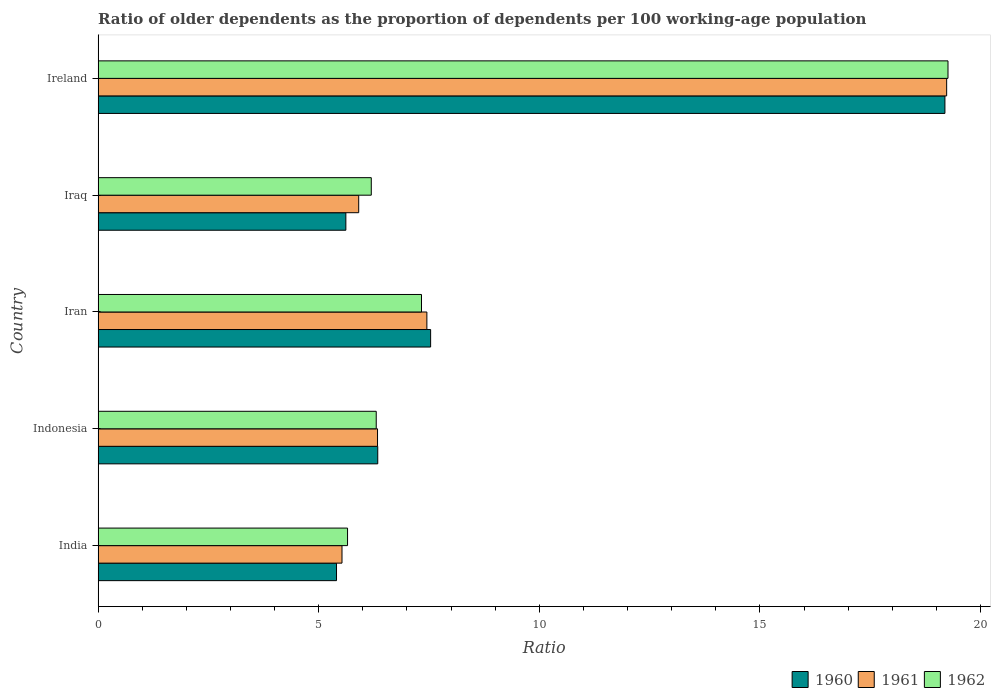How many different coloured bars are there?
Provide a short and direct response. 3. Are the number of bars per tick equal to the number of legend labels?
Your answer should be very brief. Yes. What is the label of the 2nd group of bars from the top?
Provide a short and direct response. Iraq. In how many cases, is the number of bars for a given country not equal to the number of legend labels?
Give a very brief answer. 0. What is the age dependency ratio(old) in 1961 in Iraq?
Make the answer very short. 5.91. Across all countries, what is the maximum age dependency ratio(old) in 1962?
Provide a succinct answer. 19.26. Across all countries, what is the minimum age dependency ratio(old) in 1961?
Your answer should be very brief. 5.53. In which country was the age dependency ratio(old) in 1961 maximum?
Keep it short and to the point. Ireland. What is the total age dependency ratio(old) in 1961 in the graph?
Ensure brevity in your answer.  44.45. What is the difference between the age dependency ratio(old) in 1962 in Iran and that in Ireland?
Ensure brevity in your answer.  -11.93. What is the difference between the age dependency ratio(old) in 1962 in India and the age dependency ratio(old) in 1960 in Iraq?
Provide a succinct answer. 0.04. What is the average age dependency ratio(old) in 1960 per country?
Provide a succinct answer. 8.82. What is the difference between the age dependency ratio(old) in 1962 and age dependency ratio(old) in 1961 in Iraq?
Make the answer very short. 0.28. In how many countries, is the age dependency ratio(old) in 1962 greater than 10 ?
Give a very brief answer. 1. What is the ratio of the age dependency ratio(old) in 1960 in Iran to that in Ireland?
Give a very brief answer. 0.39. Is the age dependency ratio(old) in 1961 in India less than that in Iran?
Provide a succinct answer. Yes. What is the difference between the highest and the second highest age dependency ratio(old) in 1960?
Your answer should be very brief. 11.66. What is the difference between the highest and the lowest age dependency ratio(old) in 1961?
Make the answer very short. 13.71. Is the sum of the age dependency ratio(old) in 1962 in Indonesia and Ireland greater than the maximum age dependency ratio(old) in 1961 across all countries?
Provide a succinct answer. Yes. What does the 3rd bar from the top in Iraq represents?
Your response must be concise. 1960. Is it the case that in every country, the sum of the age dependency ratio(old) in 1962 and age dependency ratio(old) in 1961 is greater than the age dependency ratio(old) in 1960?
Offer a terse response. Yes. How many countries are there in the graph?
Ensure brevity in your answer.  5. What is the difference between two consecutive major ticks on the X-axis?
Make the answer very short. 5. Does the graph contain any zero values?
Make the answer very short. No. Does the graph contain grids?
Keep it short and to the point. No. Where does the legend appear in the graph?
Keep it short and to the point. Bottom right. How many legend labels are there?
Offer a very short reply. 3. How are the legend labels stacked?
Keep it short and to the point. Horizontal. What is the title of the graph?
Your response must be concise. Ratio of older dependents as the proportion of dependents per 100 working-age population. What is the label or title of the X-axis?
Offer a very short reply. Ratio. What is the label or title of the Y-axis?
Keep it short and to the point. Country. What is the Ratio in 1960 in India?
Provide a succinct answer. 5.4. What is the Ratio of 1961 in India?
Make the answer very short. 5.53. What is the Ratio of 1962 in India?
Ensure brevity in your answer.  5.65. What is the Ratio of 1960 in Indonesia?
Keep it short and to the point. 6.34. What is the Ratio in 1961 in Indonesia?
Keep it short and to the point. 6.33. What is the Ratio in 1962 in Indonesia?
Provide a succinct answer. 6.3. What is the Ratio of 1960 in Iran?
Offer a terse response. 7.54. What is the Ratio of 1961 in Iran?
Give a very brief answer. 7.45. What is the Ratio in 1962 in Iran?
Provide a succinct answer. 7.33. What is the Ratio of 1960 in Iraq?
Your answer should be compact. 5.62. What is the Ratio of 1961 in Iraq?
Your answer should be compact. 5.91. What is the Ratio in 1962 in Iraq?
Offer a very short reply. 6.19. What is the Ratio in 1960 in Ireland?
Provide a short and direct response. 19.19. What is the Ratio in 1961 in Ireland?
Your response must be concise. 19.23. What is the Ratio in 1962 in Ireland?
Keep it short and to the point. 19.26. Across all countries, what is the maximum Ratio of 1960?
Offer a terse response. 19.19. Across all countries, what is the maximum Ratio in 1961?
Make the answer very short. 19.23. Across all countries, what is the maximum Ratio in 1962?
Make the answer very short. 19.26. Across all countries, what is the minimum Ratio in 1960?
Offer a very short reply. 5.4. Across all countries, what is the minimum Ratio in 1961?
Your answer should be very brief. 5.53. Across all countries, what is the minimum Ratio in 1962?
Your answer should be compact. 5.65. What is the total Ratio of 1960 in the graph?
Make the answer very short. 44.09. What is the total Ratio of 1961 in the graph?
Your answer should be compact. 44.45. What is the total Ratio of 1962 in the graph?
Keep it short and to the point. 44.74. What is the difference between the Ratio of 1960 in India and that in Indonesia?
Your response must be concise. -0.93. What is the difference between the Ratio in 1961 in India and that in Indonesia?
Give a very brief answer. -0.81. What is the difference between the Ratio of 1962 in India and that in Indonesia?
Provide a succinct answer. -0.65. What is the difference between the Ratio in 1960 in India and that in Iran?
Provide a short and direct response. -2.13. What is the difference between the Ratio of 1961 in India and that in Iran?
Make the answer very short. -1.92. What is the difference between the Ratio of 1962 in India and that in Iran?
Offer a very short reply. -1.68. What is the difference between the Ratio of 1960 in India and that in Iraq?
Give a very brief answer. -0.21. What is the difference between the Ratio of 1961 in India and that in Iraq?
Offer a very short reply. -0.38. What is the difference between the Ratio in 1962 in India and that in Iraq?
Provide a succinct answer. -0.54. What is the difference between the Ratio in 1960 in India and that in Ireland?
Ensure brevity in your answer.  -13.79. What is the difference between the Ratio of 1961 in India and that in Ireland?
Your answer should be very brief. -13.71. What is the difference between the Ratio in 1962 in India and that in Ireland?
Offer a very short reply. -13.61. What is the difference between the Ratio in 1960 in Indonesia and that in Iran?
Provide a succinct answer. -1.2. What is the difference between the Ratio of 1961 in Indonesia and that in Iran?
Give a very brief answer. -1.12. What is the difference between the Ratio of 1962 in Indonesia and that in Iran?
Offer a very short reply. -1.03. What is the difference between the Ratio in 1960 in Indonesia and that in Iraq?
Keep it short and to the point. 0.72. What is the difference between the Ratio of 1961 in Indonesia and that in Iraq?
Your response must be concise. 0.43. What is the difference between the Ratio in 1962 in Indonesia and that in Iraq?
Ensure brevity in your answer.  0.11. What is the difference between the Ratio of 1960 in Indonesia and that in Ireland?
Your answer should be compact. -12.86. What is the difference between the Ratio of 1961 in Indonesia and that in Ireland?
Make the answer very short. -12.9. What is the difference between the Ratio of 1962 in Indonesia and that in Ireland?
Make the answer very short. -12.96. What is the difference between the Ratio of 1960 in Iran and that in Iraq?
Ensure brevity in your answer.  1.92. What is the difference between the Ratio in 1961 in Iran and that in Iraq?
Give a very brief answer. 1.55. What is the difference between the Ratio of 1962 in Iran and that in Iraq?
Offer a terse response. 1.14. What is the difference between the Ratio in 1960 in Iran and that in Ireland?
Your answer should be very brief. -11.66. What is the difference between the Ratio in 1961 in Iran and that in Ireland?
Keep it short and to the point. -11.78. What is the difference between the Ratio in 1962 in Iran and that in Ireland?
Keep it short and to the point. -11.93. What is the difference between the Ratio in 1960 in Iraq and that in Ireland?
Provide a short and direct response. -13.58. What is the difference between the Ratio of 1961 in Iraq and that in Ireland?
Offer a terse response. -13.33. What is the difference between the Ratio in 1962 in Iraq and that in Ireland?
Keep it short and to the point. -13.07. What is the difference between the Ratio of 1960 in India and the Ratio of 1961 in Indonesia?
Your answer should be very brief. -0.93. What is the difference between the Ratio of 1960 in India and the Ratio of 1962 in Indonesia?
Your response must be concise. -0.9. What is the difference between the Ratio in 1961 in India and the Ratio in 1962 in Indonesia?
Your answer should be very brief. -0.78. What is the difference between the Ratio of 1960 in India and the Ratio of 1961 in Iran?
Provide a short and direct response. -2.05. What is the difference between the Ratio in 1960 in India and the Ratio in 1962 in Iran?
Provide a short and direct response. -1.93. What is the difference between the Ratio in 1961 in India and the Ratio in 1962 in Iran?
Offer a terse response. -1.8. What is the difference between the Ratio of 1960 in India and the Ratio of 1961 in Iraq?
Provide a succinct answer. -0.5. What is the difference between the Ratio of 1960 in India and the Ratio of 1962 in Iraq?
Your response must be concise. -0.79. What is the difference between the Ratio in 1961 in India and the Ratio in 1962 in Iraq?
Your response must be concise. -0.66. What is the difference between the Ratio in 1960 in India and the Ratio in 1961 in Ireland?
Provide a short and direct response. -13.83. What is the difference between the Ratio of 1960 in India and the Ratio of 1962 in Ireland?
Your answer should be compact. -13.86. What is the difference between the Ratio in 1961 in India and the Ratio in 1962 in Ireland?
Provide a succinct answer. -13.74. What is the difference between the Ratio of 1960 in Indonesia and the Ratio of 1961 in Iran?
Your answer should be compact. -1.11. What is the difference between the Ratio of 1960 in Indonesia and the Ratio of 1962 in Iran?
Keep it short and to the point. -0.99. What is the difference between the Ratio of 1961 in Indonesia and the Ratio of 1962 in Iran?
Make the answer very short. -1. What is the difference between the Ratio of 1960 in Indonesia and the Ratio of 1961 in Iraq?
Your response must be concise. 0.43. What is the difference between the Ratio of 1960 in Indonesia and the Ratio of 1962 in Iraq?
Offer a terse response. 0.15. What is the difference between the Ratio in 1961 in Indonesia and the Ratio in 1962 in Iraq?
Your answer should be very brief. 0.14. What is the difference between the Ratio in 1960 in Indonesia and the Ratio in 1961 in Ireland?
Make the answer very short. -12.89. What is the difference between the Ratio of 1960 in Indonesia and the Ratio of 1962 in Ireland?
Keep it short and to the point. -12.93. What is the difference between the Ratio of 1961 in Indonesia and the Ratio of 1962 in Ireland?
Your answer should be very brief. -12.93. What is the difference between the Ratio in 1960 in Iran and the Ratio in 1961 in Iraq?
Your answer should be compact. 1.63. What is the difference between the Ratio in 1960 in Iran and the Ratio in 1962 in Iraq?
Provide a short and direct response. 1.35. What is the difference between the Ratio of 1961 in Iran and the Ratio of 1962 in Iraq?
Give a very brief answer. 1.26. What is the difference between the Ratio in 1960 in Iran and the Ratio in 1961 in Ireland?
Offer a terse response. -11.7. What is the difference between the Ratio of 1960 in Iran and the Ratio of 1962 in Ireland?
Offer a terse response. -11.73. What is the difference between the Ratio in 1961 in Iran and the Ratio in 1962 in Ireland?
Give a very brief answer. -11.81. What is the difference between the Ratio in 1960 in Iraq and the Ratio in 1961 in Ireland?
Provide a succinct answer. -13.62. What is the difference between the Ratio of 1960 in Iraq and the Ratio of 1962 in Ireland?
Ensure brevity in your answer.  -13.65. What is the difference between the Ratio in 1961 in Iraq and the Ratio in 1962 in Ireland?
Give a very brief answer. -13.36. What is the average Ratio in 1960 per country?
Ensure brevity in your answer.  8.82. What is the average Ratio of 1961 per country?
Your answer should be compact. 8.89. What is the average Ratio of 1962 per country?
Your response must be concise. 8.95. What is the difference between the Ratio in 1960 and Ratio in 1961 in India?
Give a very brief answer. -0.12. What is the difference between the Ratio of 1960 and Ratio of 1962 in India?
Your response must be concise. -0.25. What is the difference between the Ratio in 1961 and Ratio in 1962 in India?
Provide a succinct answer. -0.13. What is the difference between the Ratio of 1960 and Ratio of 1961 in Indonesia?
Your answer should be compact. 0.01. What is the difference between the Ratio of 1960 and Ratio of 1962 in Indonesia?
Give a very brief answer. 0.03. What is the difference between the Ratio in 1961 and Ratio in 1962 in Indonesia?
Ensure brevity in your answer.  0.03. What is the difference between the Ratio in 1960 and Ratio in 1961 in Iran?
Give a very brief answer. 0.09. What is the difference between the Ratio in 1960 and Ratio in 1962 in Iran?
Make the answer very short. 0.21. What is the difference between the Ratio in 1961 and Ratio in 1962 in Iran?
Give a very brief answer. 0.12. What is the difference between the Ratio of 1960 and Ratio of 1961 in Iraq?
Make the answer very short. -0.29. What is the difference between the Ratio of 1960 and Ratio of 1962 in Iraq?
Your response must be concise. -0.58. What is the difference between the Ratio of 1961 and Ratio of 1962 in Iraq?
Ensure brevity in your answer.  -0.28. What is the difference between the Ratio of 1960 and Ratio of 1961 in Ireland?
Give a very brief answer. -0.04. What is the difference between the Ratio in 1960 and Ratio in 1962 in Ireland?
Give a very brief answer. -0.07. What is the difference between the Ratio of 1961 and Ratio of 1962 in Ireland?
Offer a very short reply. -0.03. What is the ratio of the Ratio of 1960 in India to that in Indonesia?
Your answer should be very brief. 0.85. What is the ratio of the Ratio of 1961 in India to that in Indonesia?
Your response must be concise. 0.87. What is the ratio of the Ratio in 1962 in India to that in Indonesia?
Keep it short and to the point. 0.9. What is the ratio of the Ratio of 1960 in India to that in Iran?
Your answer should be very brief. 0.72. What is the ratio of the Ratio in 1961 in India to that in Iran?
Provide a short and direct response. 0.74. What is the ratio of the Ratio of 1962 in India to that in Iran?
Keep it short and to the point. 0.77. What is the ratio of the Ratio of 1960 in India to that in Iraq?
Give a very brief answer. 0.96. What is the ratio of the Ratio of 1961 in India to that in Iraq?
Provide a short and direct response. 0.94. What is the ratio of the Ratio in 1962 in India to that in Iraq?
Provide a short and direct response. 0.91. What is the ratio of the Ratio in 1960 in India to that in Ireland?
Ensure brevity in your answer.  0.28. What is the ratio of the Ratio of 1961 in India to that in Ireland?
Give a very brief answer. 0.29. What is the ratio of the Ratio of 1962 in India to that in Ireland?
Give a very brief answer. 0.29. What is the ratio of the Ratio of 1960 in Indonesia to that in Iran?
Your answer should be compact. 0.84. What is the ratio of the Ratio of 1961 in Indonesia to that in Iran?
Your answer should be compact. 0.85. What is the ratio of the Ratio of 1962 in Indonesia to that in Iran?
Your answer should be very brief. 0.86. What is the ratio of the Ratio of 1960 in Indonesia to that in Iraq?
Keep it short and to the point. 1.13. What is the ratio of the Ratio of 1961 in Indonesia to that in Iraq?
Offer a very short reply. 1.07. What is the ratio of the Ratio in 1962 in Indonesia to that in Iraq?
Give a very brief answer. 1.02. What is the ratio of the Ratio in 1960 in Indonesia to that in Ireland?
Offer a terse response. 0.33. What is the ratio of the Ratio in 1961 in Indonesia to that in Ireland?
Your response must be concise. 0.33. What is the ratio of the Ratio in 1962 in Indonesia to that in Ireland?
Provide a short and direct response. 0.33. What is the ratio of the Ratio of 1960 in Iran to that in Iraq?
Offer a very short reply. 1.34. What is the ratio of the Ratio in 1961 in Iran to that in Iraq?
Make the answer very short. 1.26. What is the ratio of the Ratio of 1962 in Iran to that in Iraq?
Provide a succinct answer. 1.18. What is the ratio of the Ratio of 1960 in Iran to that in Ireland?
Your response must be concise. 0.39. What is the ratio of the Ratio in 1961 in Iran to that in Ireland?
Provide a succinct answer. 0.39. What is the ratio of the Ratio of 1962 in Iran to that in Ireland?
Your response must be concise. 0.38. What is the ratio of the Ratio of 1960 in Iraq to that in Ireland?
Give a very brief answer. 0.29. What is the ratio of the Ratio in 1961 in Iraq to that in Ireland?
Your answer should be very brief. 0.31. What is the ratio of the Ratio in 1962 in Iraq to that in Ireland?
Offer a very short reply. 0.32. What is the difference between the highest and the second highest Ratio in 1960?
Give a very brief answer. 11.66. What is the difference between the highest and the second highest Ratio of 1961?
Provide a succinct answer. 11.78. What is the difference between the highest and the second highest Ratio of 1962?
Your response must be concise. 11.93. What is the difference between the highest and the lowest Ratio of 1960?
Give a very brief answer. 13.79. What is the difference between the highest and the lowest Ratio of 1961?
Your answer should be very brief. 13.71. What is the difference between the highest and the lowest Ratio in 1962?
Offer a terse response. 13.61. 